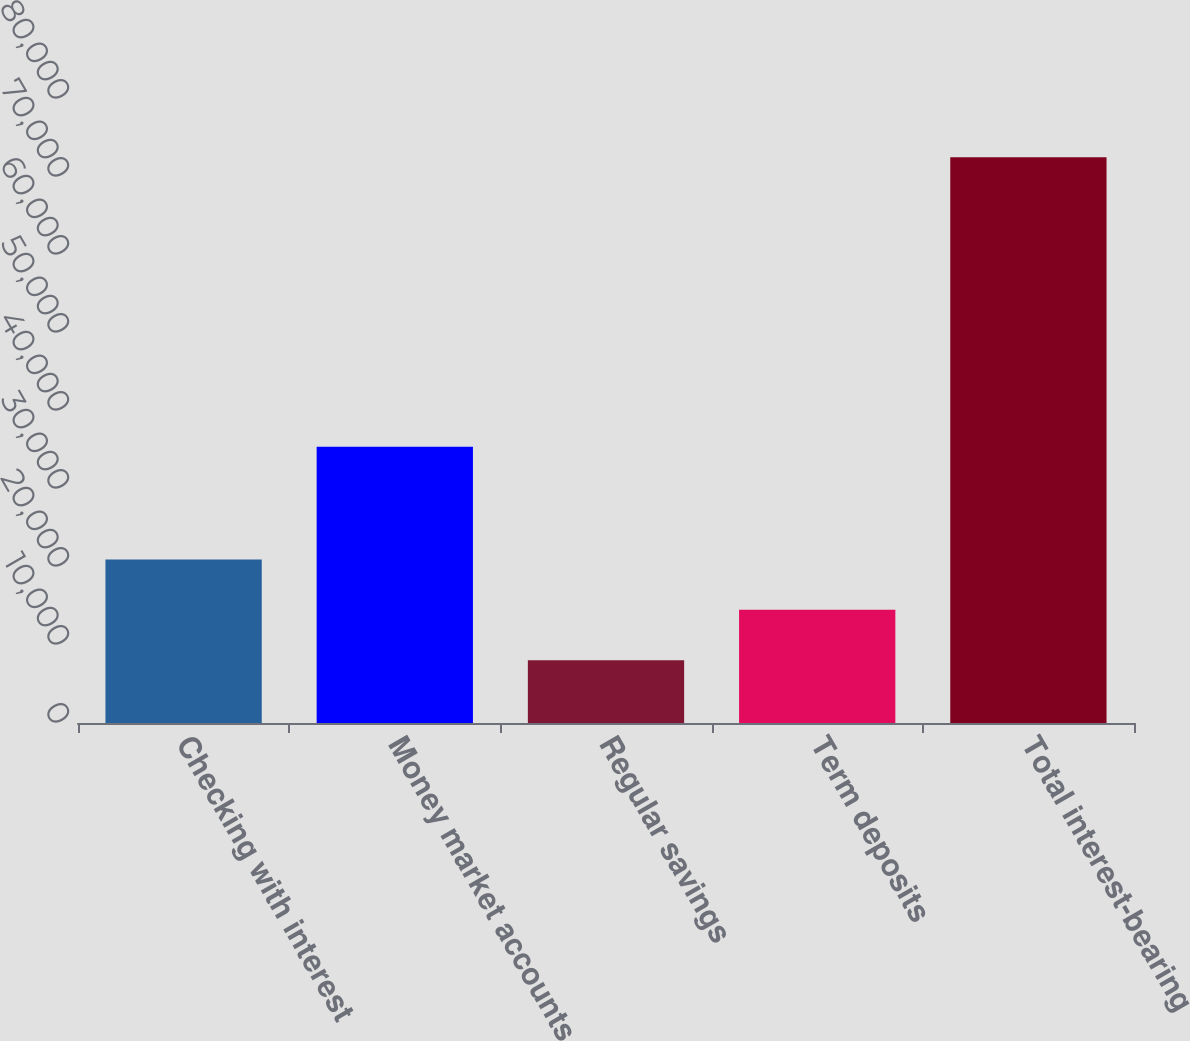<chart> <loc_0><loc_0><loc_500><loc_500><bar_chart><fcel>Checking with interest<fcel>Money market accounts<fcel>Regular savings<fcel>Term deposits<fcel>Total interest-bearing<nl><fcel>20955.2<fcel>35401<fcel>8057<fcel>14506.1<fcel>72548<nl></chart> 